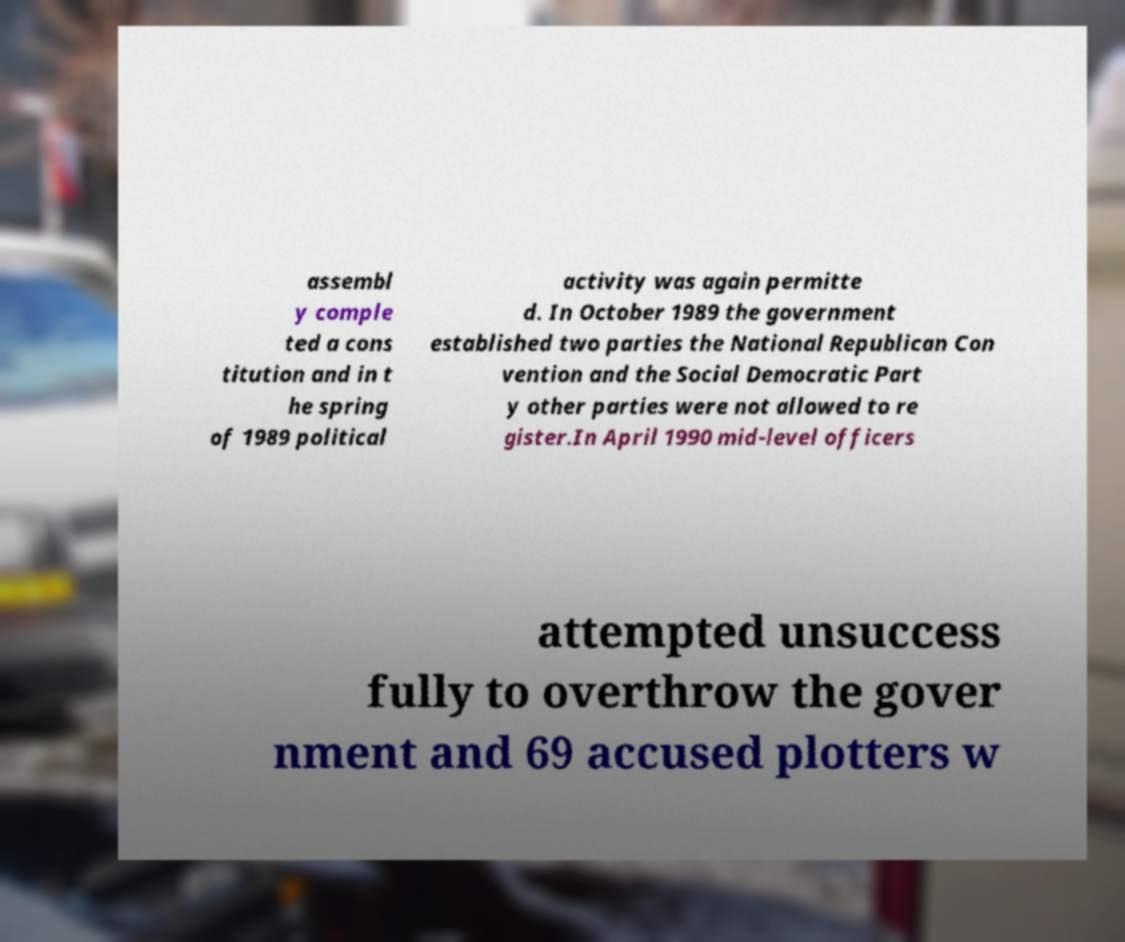Could you extract and type out the text from this image? assembl y comple ted a cons titution and in t he spring of 1989 political activity was again permitte d. In October 1989 the government established two parties the National Republican Con vention and the Social Democratic Part y other parties were not allowed to re gister.In April 1990 mid-level officers attempted unsuccess fully to overthrow the gover nment and 69 accused plotters w 